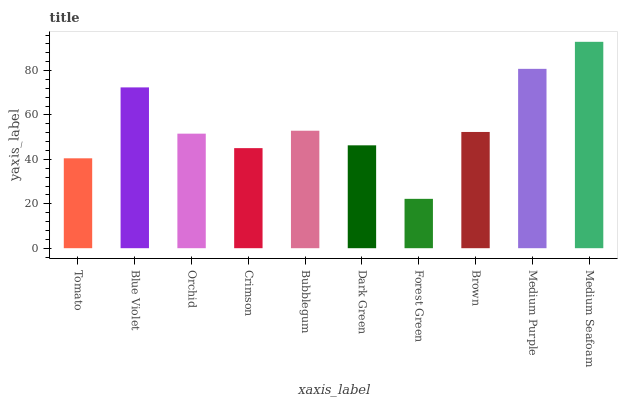Is Forest Green the minimum?
Answer yes or no. Yes. Is Medium Seafoam the maximum?
Answer yes or no. Yes. Is Blue Violet the minimum?
Answer yes or no. No. Is Blue Violet the maximum?
Answer yes or no. No. Is Blue Violet greater than Tomato?
Answer yes or no. Yes. Is Tomato less than Blue Violet?
Answer yes or no. Yes. Is Tomato greater than Blue Violet?
Answer yes or no. No. Is Blue Violet less than Tomato?
Answer yes or no. No. Is Brown the high median?
Answer yes or no. Yes. Is Orchid the low median?
Answer yes or no. Yes. Is Medium Seafoam the high median?
Answer yes or no. No. Is Bubblegum the low median?
Answer yes or no. No. 